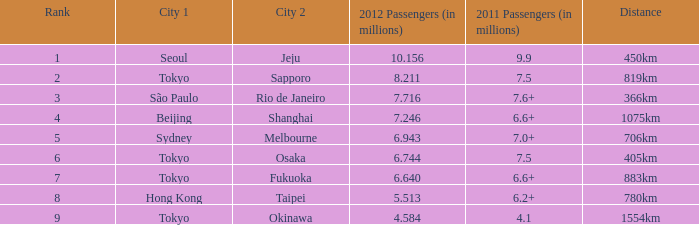6+ million passengers in 2011 and a length of 1075km? Beijing. 